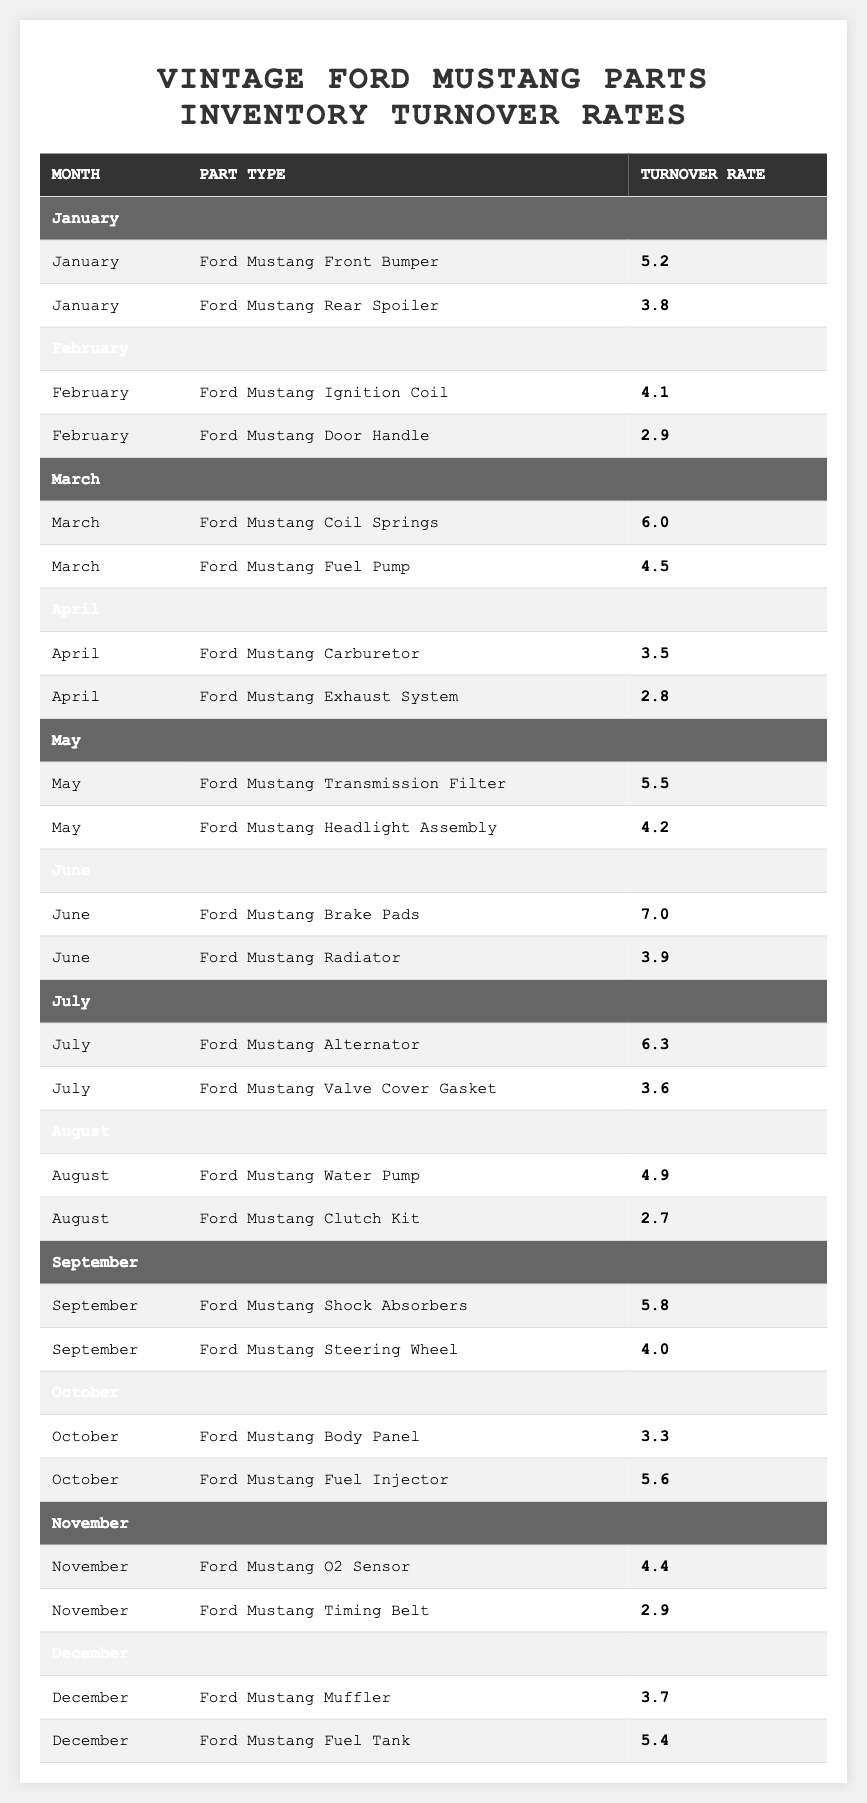What is the highest turnover rate for any part type in June? In June, the turnover rates for parts are: Brake Pads (7.0) and Radiator (3.9). The highest rate is 7.0 for Brake Pads.
Answer: 7.0 Which month had the highest turnover rate for any part type? The highest individual turnover rate across all months is 7.0 for Brake Pads in June, hence June has the highest turnover rate.
Answer: June What is the average turnover rate for Ford Mustang parts sold in April? The turnover rates in April are 3.5 for Carburetor and 2.8 for Exhaust System. The average is calculated as (3.5 + 2.8) / 2 = 3.15.
Answer: 3.15 How many parts had a turnover rate of over 5.0 in May? In May, the turnover rates are 5.5 for Transmission Filter and 4.2 for Headlight Assembly. Only 1 part (Transmission Filter) has a turnover rate over 5.0.
Answer: 1 Is the turnover rate for the Ford Mustang Clutch Kit in August greater than that of the Ford Mustang Rear Spoiler in January? The turnover rate for Clutch Kit in August is 2.7, while for Rear Spoiler in January it is 3.8. Since 2.7 is less than 3.8, it's false.
Answer: No What is the total turnover rate for all parts sold in September? In September, the turnover rates are 5.8 for Shock Absorbers and 4.0 for Steering Wheel, thus the total turnover rate is 5.8 + 4.0 = 9.8.
Answer: 9.8 What is the difference in turnover rates between the Ford Mustang Body Panel in October and the Ford Mustang Fuel Injector in October? In October, the Body Panel has a turnover rate of 3.3 and the Fuel Injector has 5.6. The difference is 5.6 - 3.3 = 2.3.
Answer: 2.3 Which part type had the lowest turnover rate across the entire year? Examining the turnover rates for all months, the lowest rate observed is 2.7 for the Ford Mustang Clutch Kit in August.
Answer: Ford Mustang Clutch Kit How many parts had turnover rates of 5.0 or higher from January to December? The parts and their rates for these are: Front Bumper (5.2), Coil Springs (6.0), Transmission Filter (5.5), Brake Pads (7.0), Alternator (6.3), Shock Absorbers (5.8), Fuel Injector (5.6), and Fuel Tank (5.4), totaling 8 parts with rates over 5.0.
Answer: 8 In which month were more than two parts listed with their turnover rates? In March 2 parts were listed, April 2 parts, May 2 parts, June 2 parts, July 2 parts, August 2 parts, September 2 parts, October 2 parts, November 2 parts, and December 2 parts. All months had only 2 parts. Hence, there are no months with more than 2 parts listed.
Answer: None 